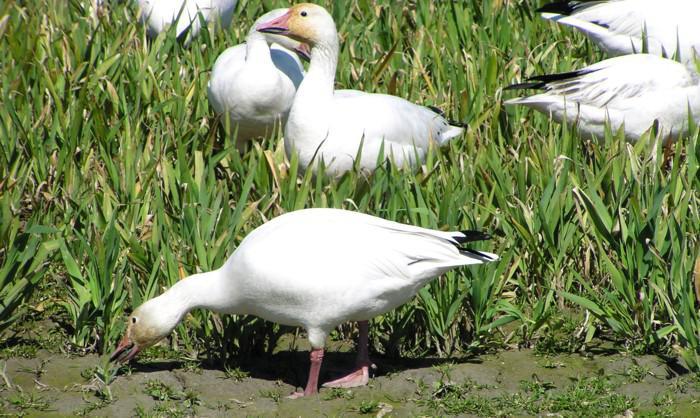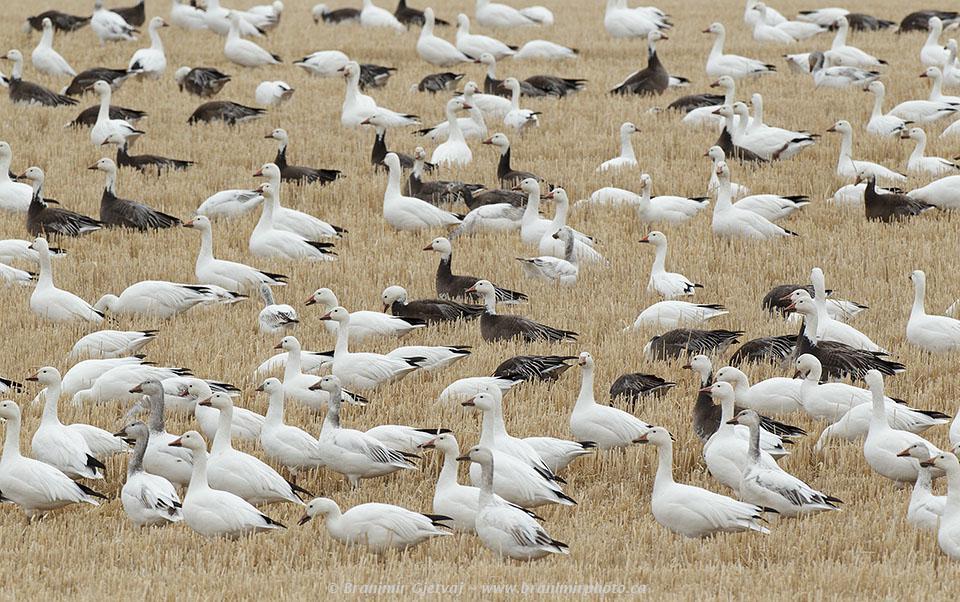The first image is the image on the left, the second image is the image on the right. Given the left and right images, does the statement "There are no more than three birds in the left image." hold true? Answer yes or no. No. The first image is the image on the left, the second image is the image on the right. Examine the images to the left and right. Is the description "At least one of the images has geese in brown grass." accurate? Answer yes or no. Yes. 